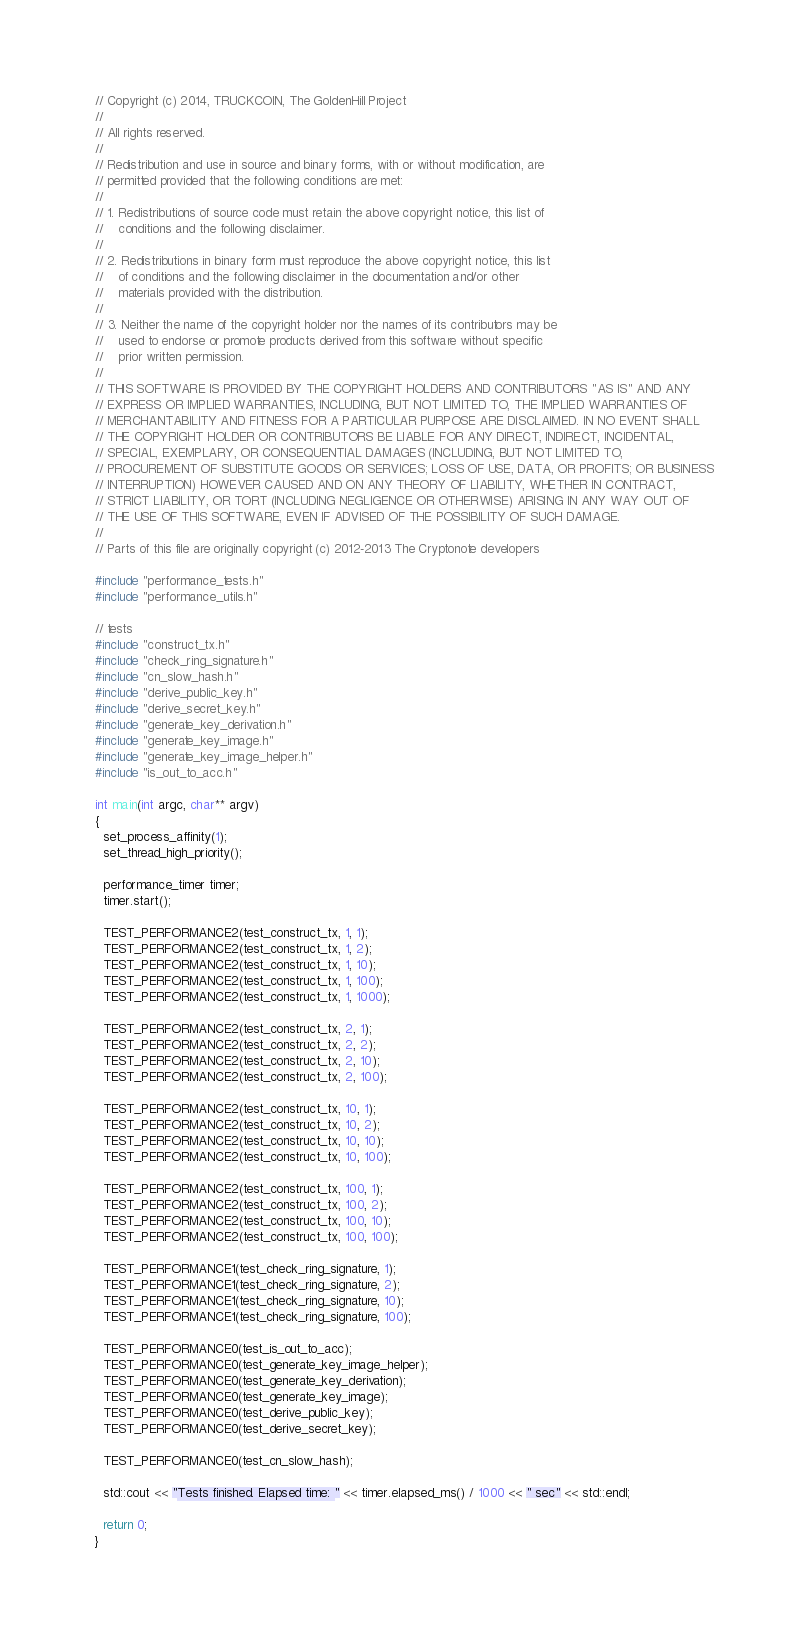Convert code to text. <code><loc_0><loc_0><loc_500><loc_500><_C++_>// Copyright (c) 2014, TRUCKCOIN, The GoldenHill Project
// 
// All rights reserved.
// 
// Redistribution and use in source and binary forms, with or without modification, are
// permitted provided that the following conditions are met:
// 
// 1. Redistributions of source code must retain the above copyright notice, this list of
//    conditions and the following disclaimer.
// 
// 2. Redistributions in binary form must reproduce the above copyright notice, this list
//    of conditions and the following disclaimer in the documentation and/or other
//    materials provided with the distribution.
// 
// 3. Neither the name of the copyright holder nor the names of its contributors may be
//    used to endorse or promote products derived from this software without specific
//    prior written permission.
// 
// THIS SOFTWARE IS PROVIDED BY THE COPYRIGHT HOLDERS AND CONTRIBUTORS "AS IS" AND ANY
// EXPRESS OR IMPLIED WARRANTIES, INCLUDING, BUT NOT LIMITED TO, THE IMPLIED WARRANTIES OF
// MERCHANTABILITY AND FITNESS FOR A PARTICULAR PURPOSE ARE DISCLAIMED. IN NO EVENT SHALL
// THE COPYRIGHT HOLDER OR CONTRIBUTORS BE LIABLE FOR ANY DIRECT, INDIRECT, INCIDENTAL,
// SPECIAL, EXEMPLARY, OR CONSEQUENTIAL DAMAGES (INCLUDING, BUT NOT LIMITED TO,
// PROCUREMENT OF SUBSTITUTE GOODS OR SERVICES; LOSS OF USE, DATA, OR PROFITS; OR BUSINESS
// INTERRUPTION) HOWEVER CAUSED AND ON ANY THEORY OF LIABILITY, WHETHER IN CONTRACT,
// STRICT LIABILITY, OR TORT (INCLUDING NEGLIGENCE OR OTHERWISE) ARISING IN ANY WAY OUT OF
// THE USE OF THIS SOFTWARE, EVEN IF ADVISED OF THE POSSIBILITY OF SUCH DAMAGE.
// 
// Parts of this file are originally copyright (c) 2012-2013 The Cryptonote developers

#include "performance_tests.h"
#include "performance_utils.h"

// tests
#include "construct_tx.h"
#include "check_ring_signature.h"
#include "cn_slow_hash.h"
#include "derive_public_key.h"
#include "derive_secret_key.h"
#include "generate_key_derivation.h"
#include "generate_key_image.h"
#include "generate_key_image_helper.h"
#include "is_out_to_acc.h"

int main(int argc, char** argv)
{
  set_process_affinity(1);
  set_thread_high_priority();

  performance_timer timer;
  timer.start();

  TEST_PERFORMANCE2(test_construct_tx, 1, 1);
  TEST_PERFORMANCE2(test_construct_tx, 1, 2);
  TEST_PERFORMANCE2(test_construct_tx, 1, 10);
  TEST_PERFORMANCE2(test_construct_tx, 1, 100);
  TEST_PERFORMANCE2(test_construct_tx, 1, 1000);

  TEST_PERFORMANCE2(test_construct_tx, 2, 1);
  TEST_PERFORMANCE2(test_construct_tx, 2, 2);
  TEST_PERFORMANCE2(test_construct_tx, 2, 10);
  TEST_PERFORMANCE2(test_construct_tx, 2, 100);

  TEST_PERFORMANCE2(test_construct_tx, 10, 1);
  TEST_PERFORMANCE2(test_construct_tx, 10, 2);
  TEST_PERFORMANCE2(test_construct_tx, 10, 10);
  TEST_PERFORMANCE2(test_construct_tx, 10, 100);

  TEST_PERFORMANCE2(test_construct_tx, 100, 1);
  TEST_PERFORMANCE2(test_construct_tx, 100, 2);
  TEST_PERFORMANCE2(test_construct_tx, 100, 10);
  TEST_PERFORMANCE2(test_construct_tx, 100, 100);

  TEST_PERFORMANCE1(test_check_ring_signature, 1);
  TEST_PERFORMANCE1(test_check_ring_signature, 2);
  TEST_PERFORMANCE1(test_check_ring_signature, 10);
  TEST_PERFORMANCE1(test_check_ring_signature, 100);

  TEST_PERFORMANCE0(test_is_out_to_acc);
  TEST_PERFORMANCE0(test_generate_key_image_helper);
  TEST_PERFORMANCE0(test_generate_key_derivation);
  TEST_PERFORMANCE0(test_generate_key_image);
  TEST_PERFORMANCE0(test_derive_public_key);
  TEST_PERFORMANCE0(test_derive_secret_key);

  TEST_PERFORMANCE0(test_cn_slow_hash);

  std::cout << "Tests finished. Elapsed time: " << timer.elapsed_ms() / 1000 << " sec" << std::endl;

  return 0;
}
</code> 